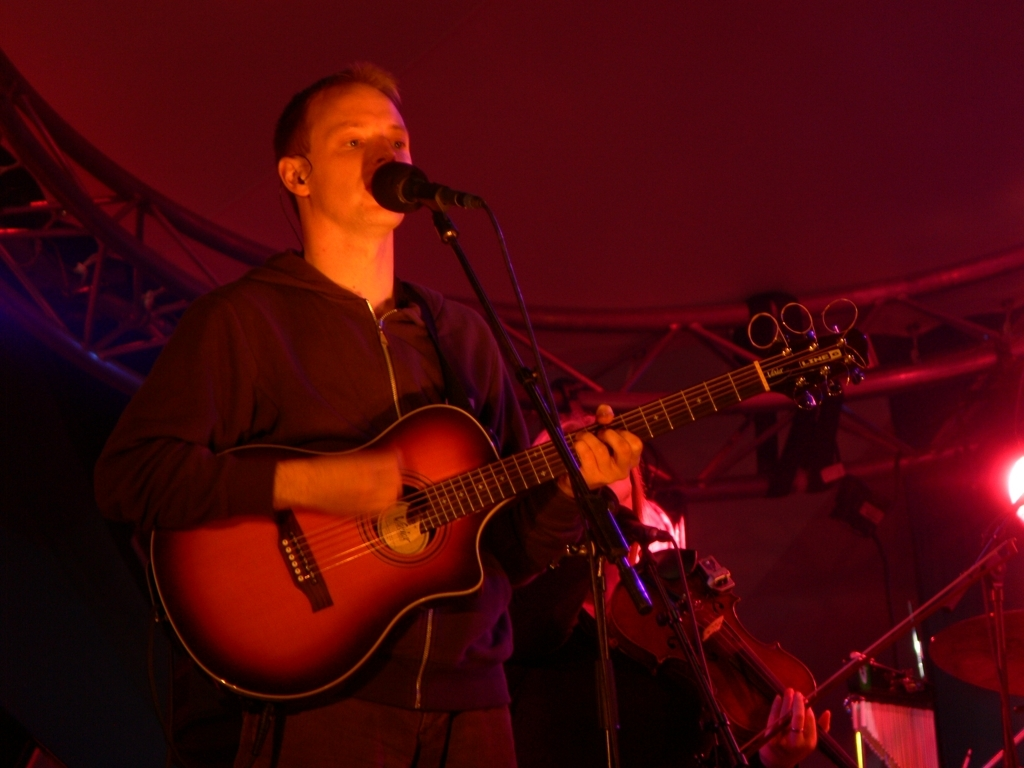What emotions does the performer seem to convey through his expression and posture? The performer appears to be immersed in the music, conveying a sense of focused intensity and passion for the art. His closed eyes and the slight opening of his mouth suggest a deep emotional connection to the song being played. 